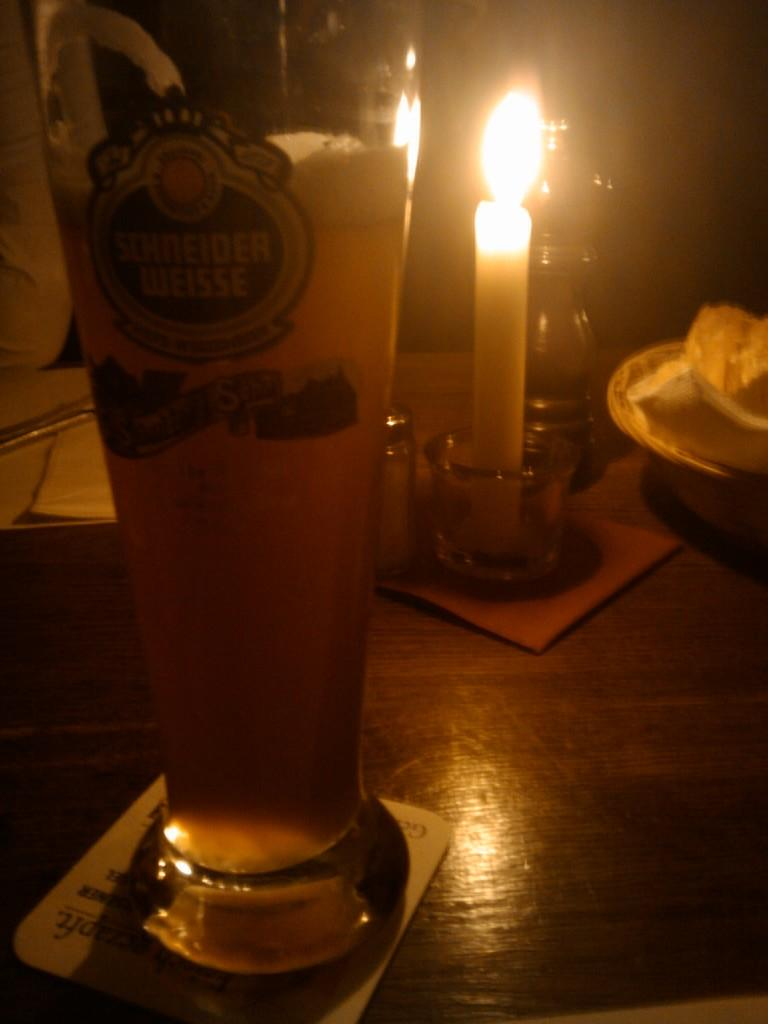What type of table is in the image? There is a wooden table in the image. What is on the table? There is a glass of beer, a candle, a small bottle, tissues, and a bowl on the table. What might be used for lighting in the image? There is a candle on the table. What might be used for cleaning or wiping in the image? Tissues are present on the table. What type of curtain is hanging near the table in the image? There is no curtain present in the image. How many chairs are around the table in the image? The image does not show any chairs around the table, so it is not possible to determine the number of chairs. 